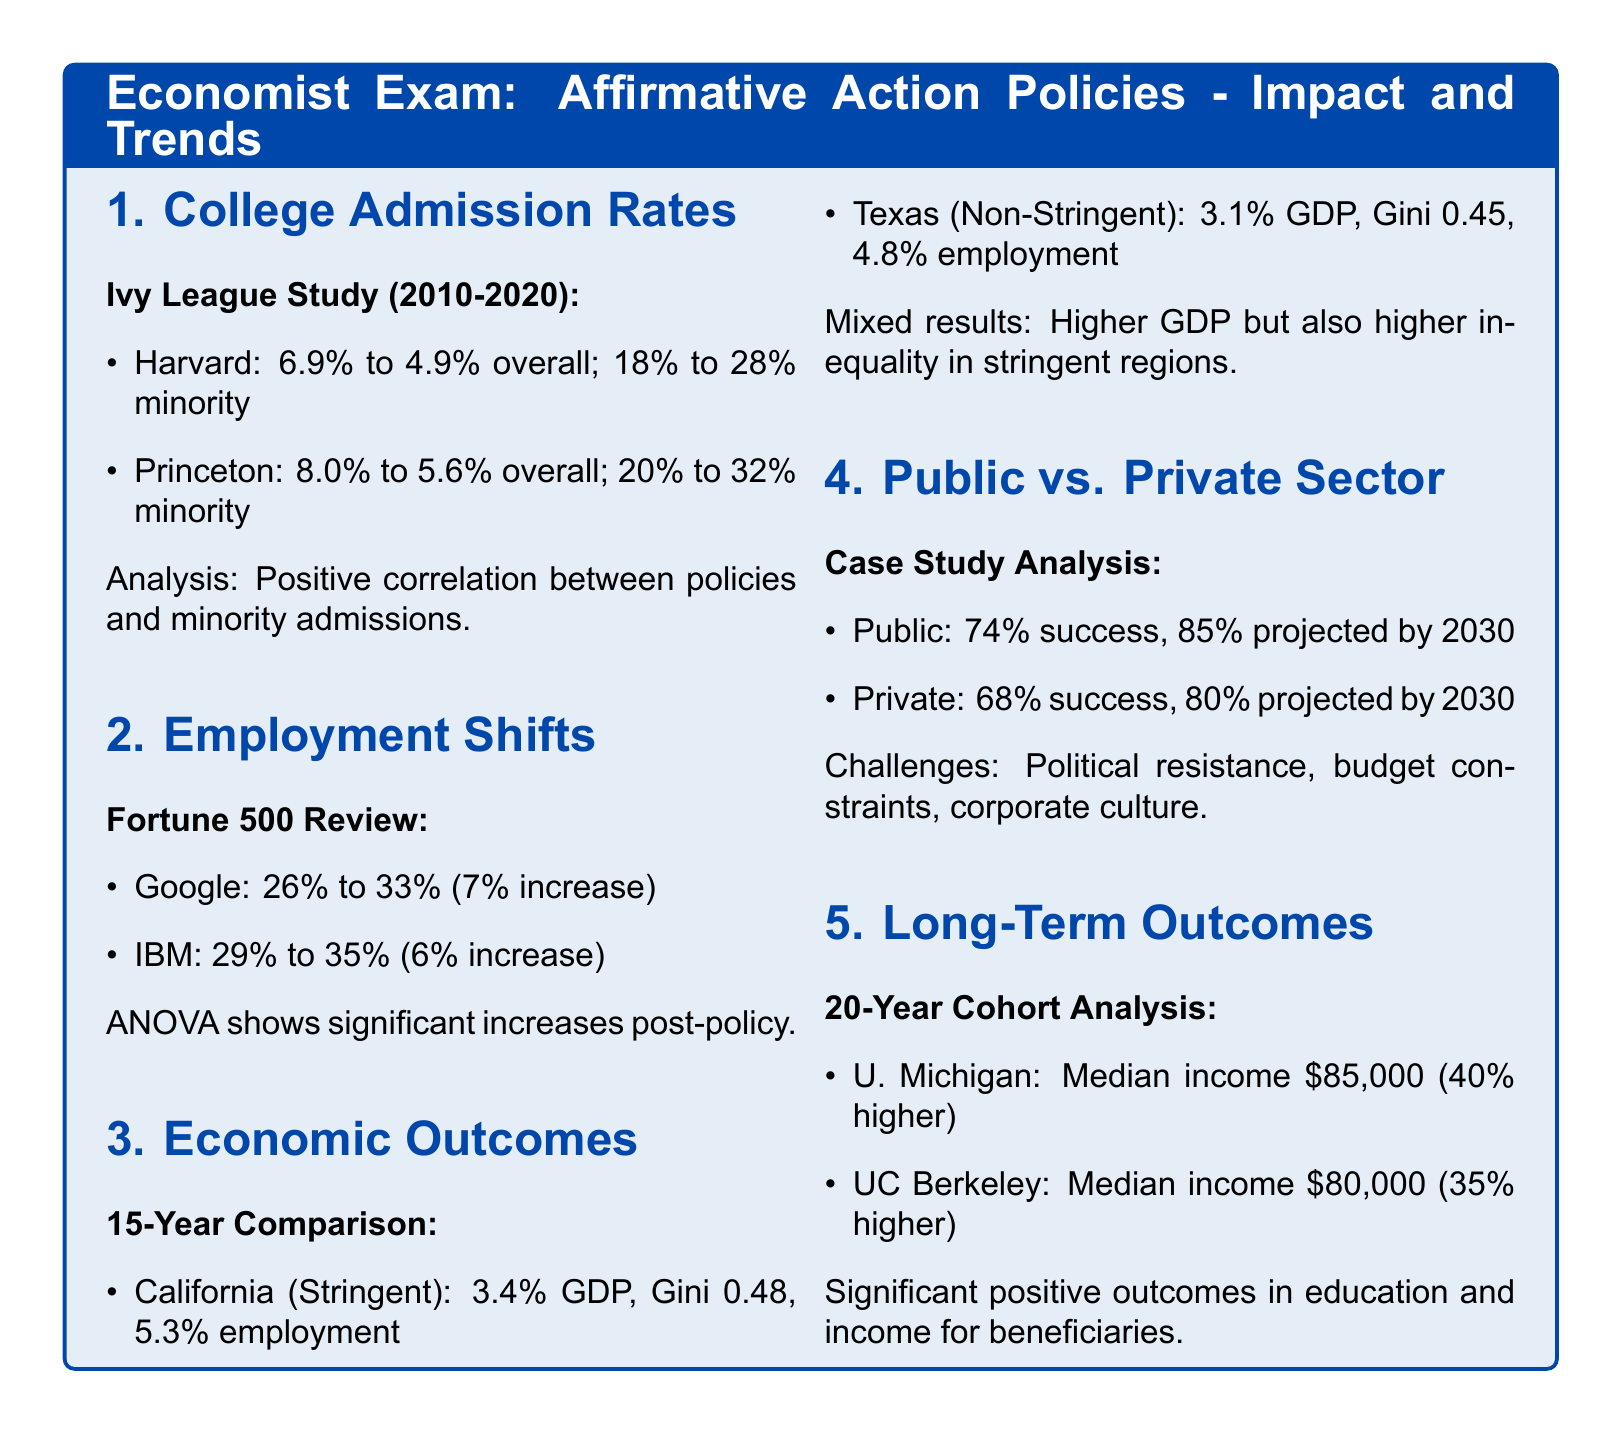What was Harvard's minority admission rate in 2020? The document states that Harvard's minority admission rate increased to 28% in 2020.
Answer: 28% What is the percentage increase in Google’s minority employment? The document provides that Google’s minority employment increased from 26% to 33%, which is a 7% increase.
Answer: 7% What Gini coefficient did California have? The document mentions that California had a Gini coefficient of 0.48.
Answer: 0.48 What is the projected success rate for public sector affirmative action policies by 2030? According to the document, the projected success rate for public sector affirmative action policies is 85% by 2030.
Answer: 85% What was the median income after 20 years for University of Michigan beneficiaries? The document states that the median income for beneficiaries of the University of Michigan is $85,000.
Answer: $85,000 Is there a higher GDP growth in regions with stringent affirmative action laws? The document indicates that California (stringent) had a GDP growth of 3.4%, which is higher than Texas (non-stringent) at 3.1%.
Answer: Yes What percentage of success was reported in the private sector for affirmative action policies? The document states that the success rate reported in the private sector is 68%.
Answer: 68% What was the overall admission rate decline for Princeton from 2010 to 2020? The document specifies that Princeton's overall admission rate declined from 8.0% to 5.6%.
Answer: 2.4% 